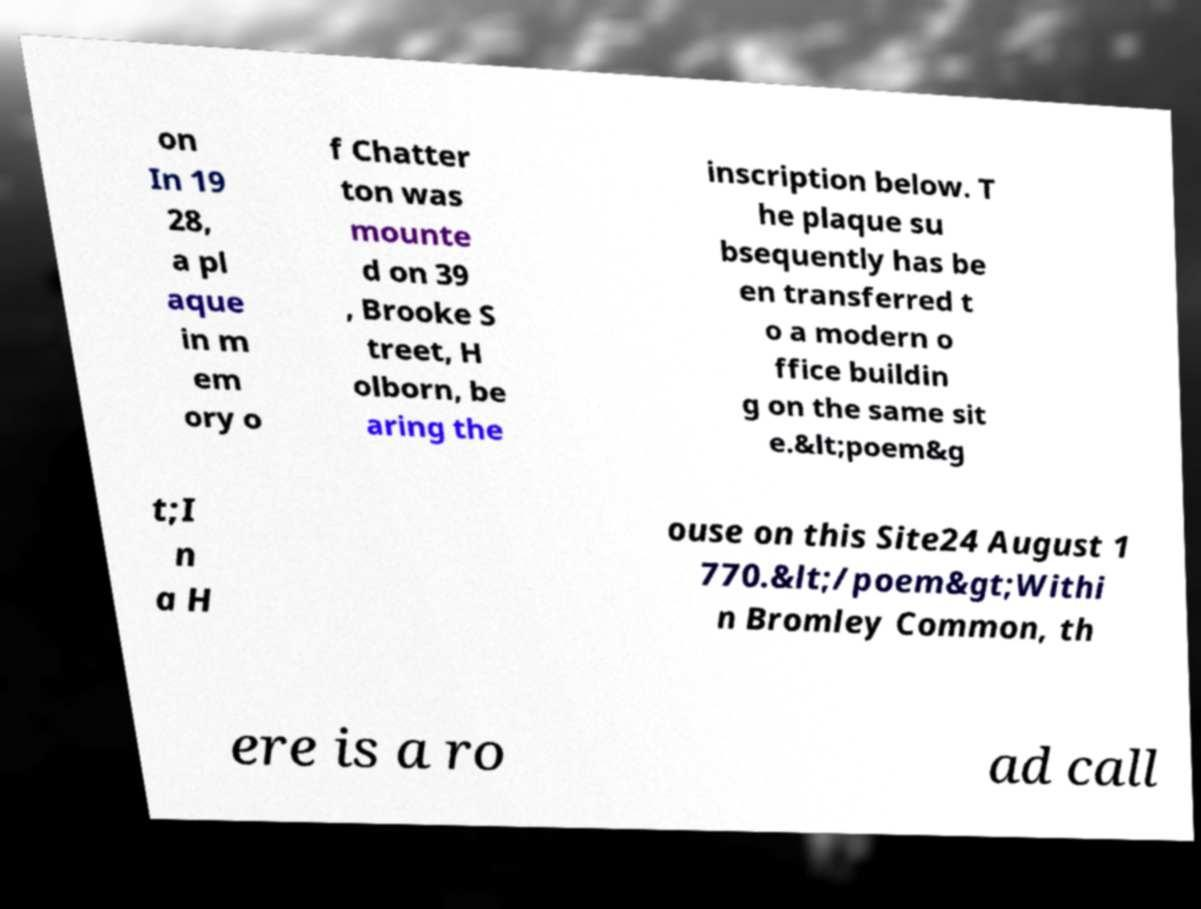For documentation purposes, I need the text within this image transcribed. Could you provide that? on In 19 28, a pl aque in m em ory o f Chatter ton was mounte d on 39 , Brooke S treet, H olborn, be aring the inscription below. T he plaque su bsequently has be en transferred t o a modern o ffice buildin g on the same sit e.&lt;poem&g t;I n a H ouse on this Site24 August 1 770.&lt;/poem&gt;Withi n Bromley Common, th ere is a ro ad call 